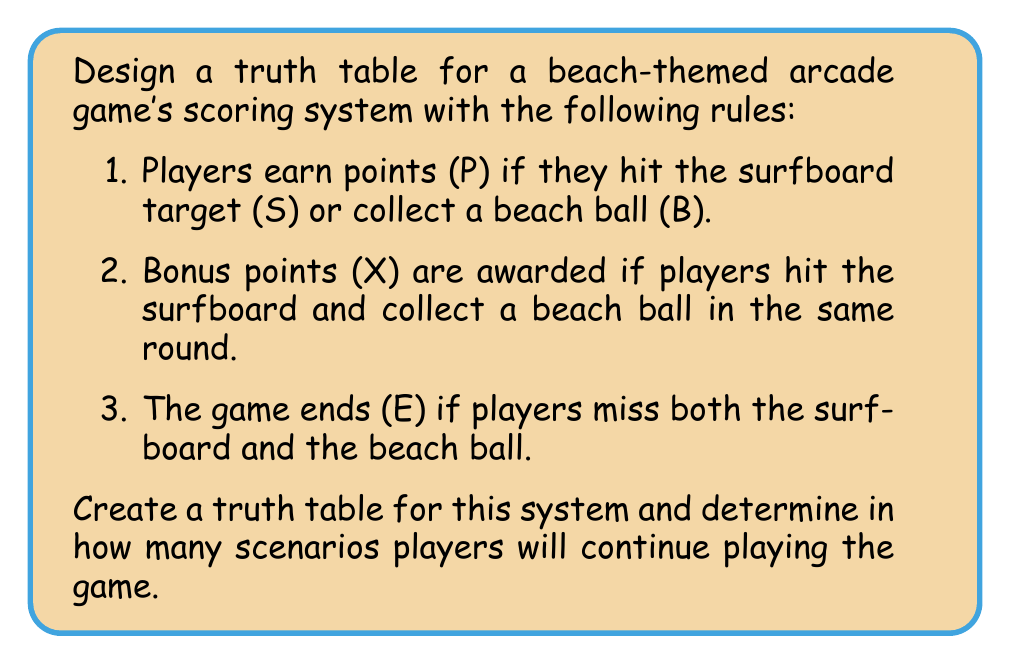Could you help me with this problem? Let's approach this step-by-step:

1) First, we need to identify our variables:
   S: Hit the surfboard
   B: Collect a beach ball
   P: Earn points
   X: Earn bonus points
   E: Game ends

2) Now, let's write out the logical expressions:
   $P = S \lor B$ (Players earn points if they hit the surfboard OR collect a beach ball)
   $X = S \land B$ (Bonus points are awarded if players hit the surfboard AND collect a beach ball)
   $E = \lnot S \land \lnot B$ (Game ends if players miss both the surfboard AND the beach ball)

3) Let's create the truth table:

   $$
   \begin{array}{|c|c|c|c|c|}
   \hline 
   S & B & P & X & E \\
   \hline
   0 & 0 & 0 & 0 & 1 \\
   0 & 1 & 1 & 0 & 0 \\
   1 & 0 & 1 & 0 & 0 \\
   1 & 1 & 1 & 1 & 0 \\
   \hline
   \end{array}
   $$

4) To determine in how many scenarios players will continue playing, we need to count the rows where E = 0.

5) Counting the rows where E = 0, we find 3 scenarios where the game continues.
Answer: 3 scenarios 